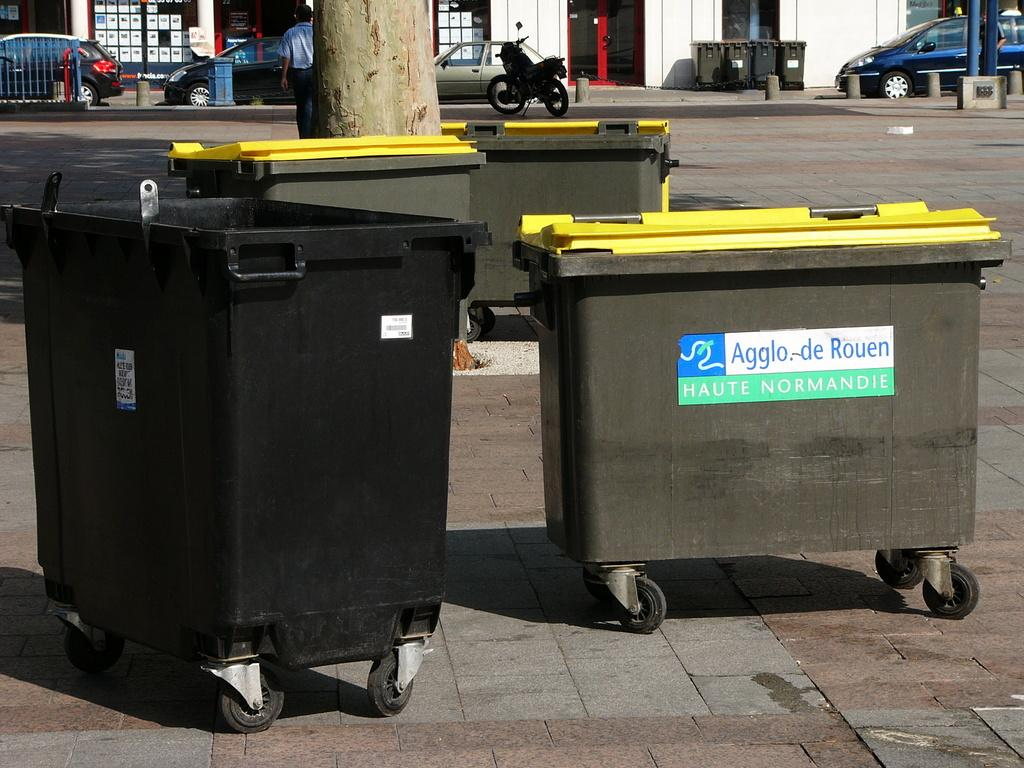<image>
Create a compact narrative representing the image presented. Large bins on wheels that say Agglo De Rouen. 